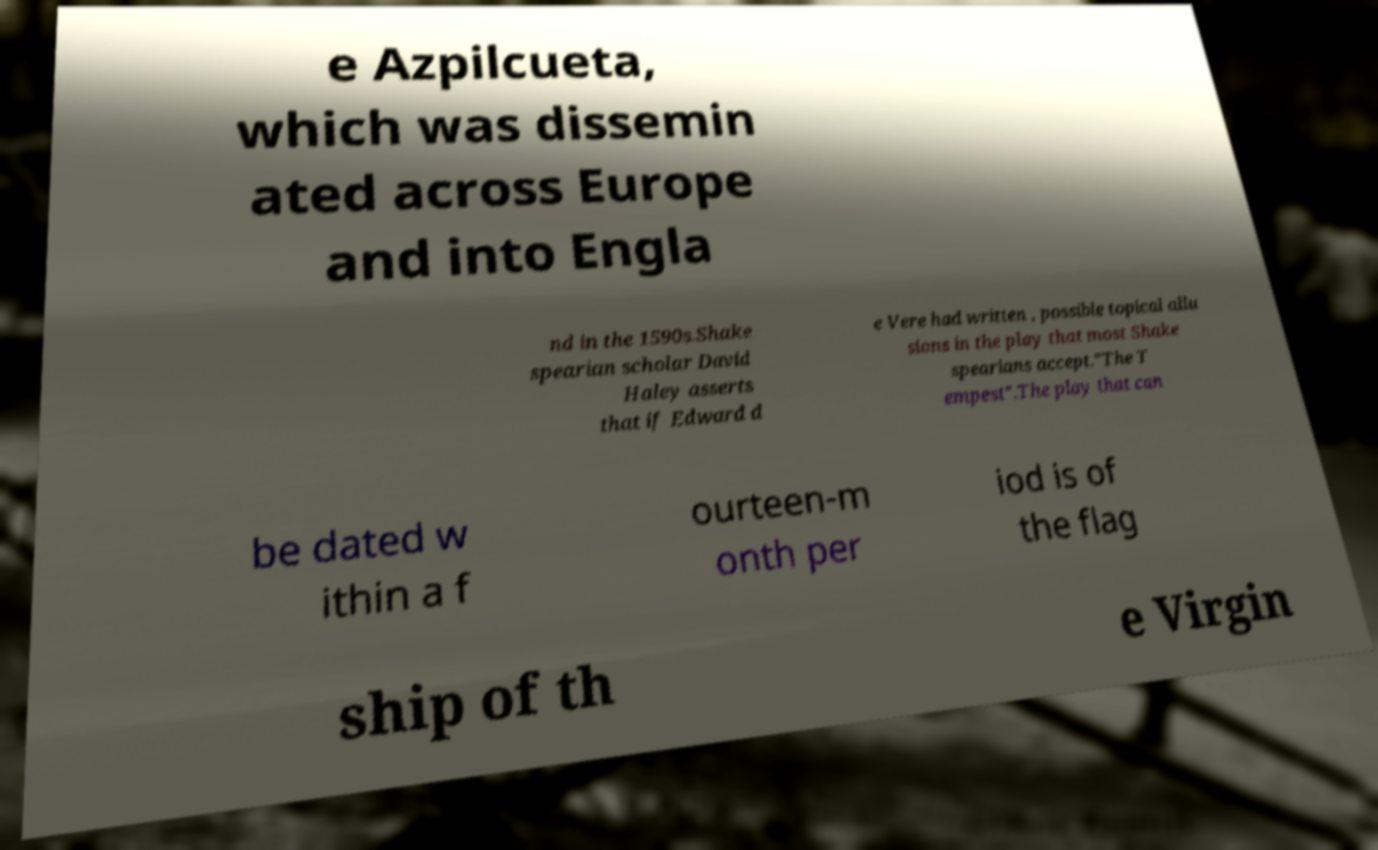Please read and relay the text visible in this image. What does it say? e Azpilcueta, which was dissemin ated across Europe and into Engla nd in the 1590s.Shake spearian scholar David Haley asserts that if Edward d e Vere had written , possible topical allu sions in the play that most Shake spearians accept."The T empest".The play that can be dated w ithin a f ourteen-m onth per iod is of the flag ship of th e Virgin 